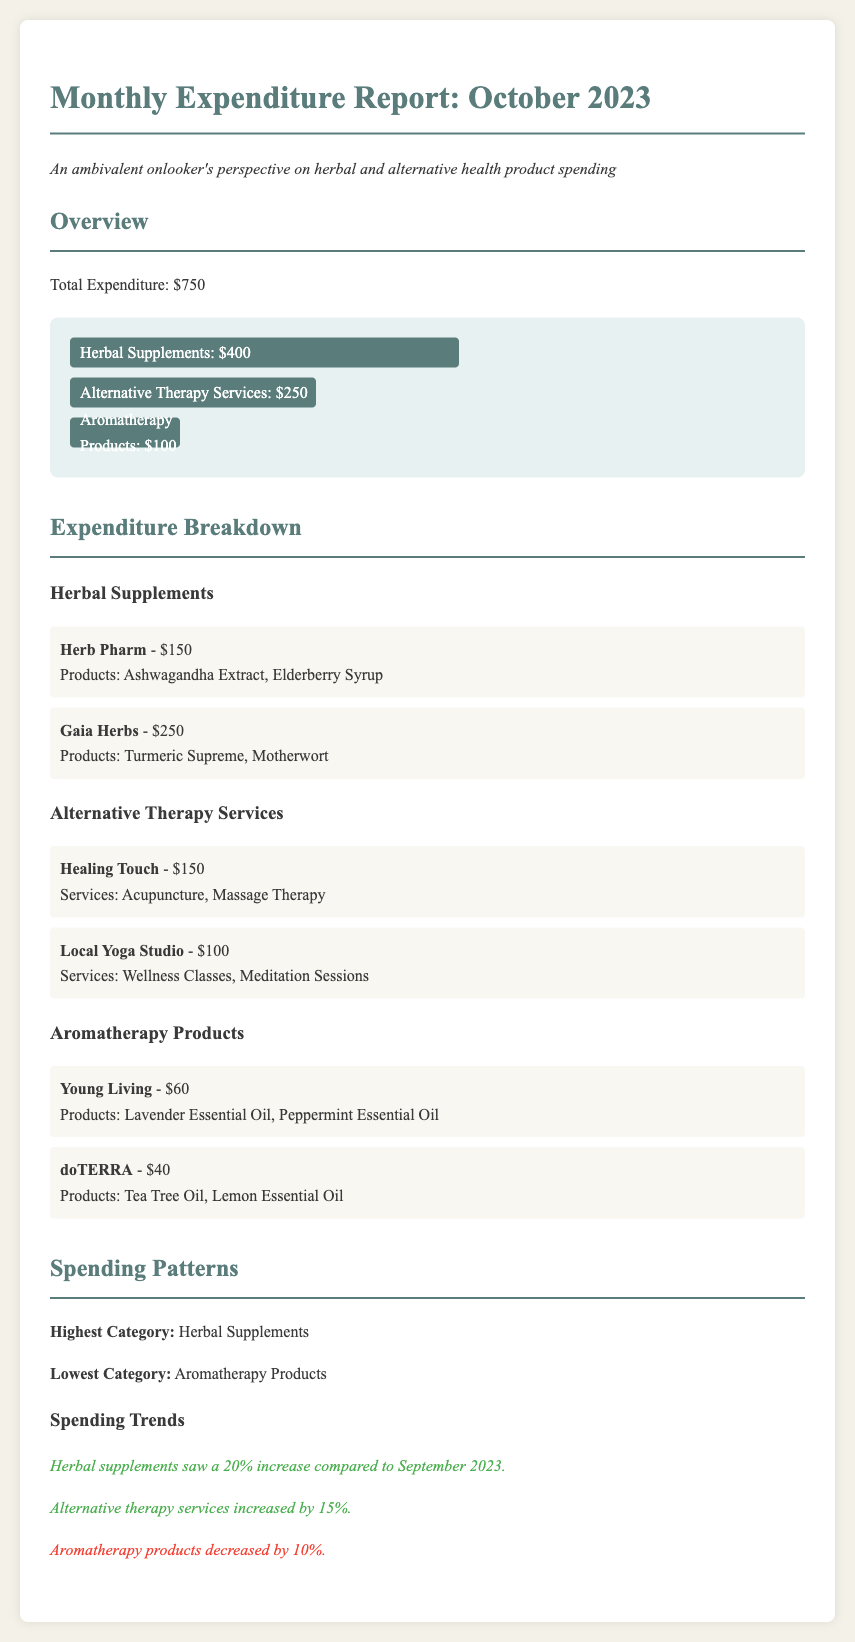What is the total expenditure for October 2023? The total expenditure is stated clearly in the overview section of the document.
Answer: $750 Which category has the highest expenditure? The highest category is identified within the spending patterns section.
Answer: Herbal Supplements What is the amount spent on alternative therapy services? The amount is specified in the expenditure breakdown of alternative therapy services.
Answer: $250 Which vendor provided the most expensive herbal supplement? The vendor with the most expensive herbal supplement is mentioned under herbal supplements.
Answer: Gaia Herbs By what percentage did herbal supplements increase compared to September 2023? The percentage increase for herbal supplements is indicated in the spending trends section.
Answer: 20% How much was spent on aromatherapy products? The total amount spent on aromatherapy products is given in the expenditure breakdown section.
Answer: $100 What was the amount spent at Young Living? The amount spent at Young Living is listed under aromatherapy products.
Answer: $60 Which service was provided by the Local Yoga Studio? The services provided by the Local Yoga Studio are described in the expenditure breakdown section.
Answer: Wellness Classes, Meditation Sessions 